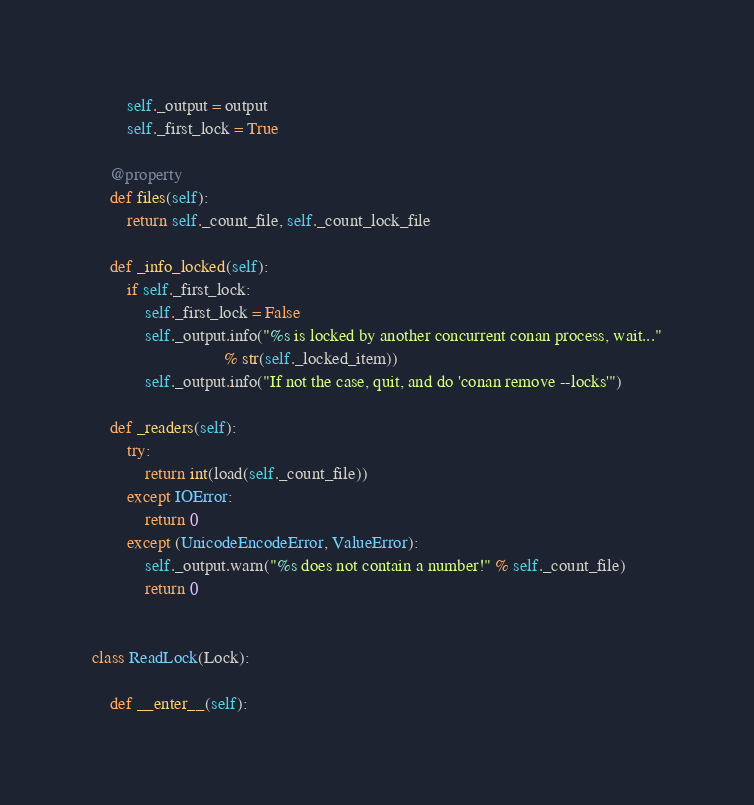<code> <loc_0><loc_0><loc_500><loc_500><_Python_>        self._output = output
        self._first_lock = True

    @property
    def files(self):
        return self._count_file, self._count_lock_file

    def _info_locked(self):
        if self._first_lock:
            self._first_lock = False
            self._output.info("%s is locked by another concurrent conan process, wait..."
                              % str(self._locked_item))
            self._output.info("If not the case, quit, and do 'conan remove --locks'")

    def _readers(self):
        try:
            return int(load(self._count_file))
        except IOError:
            return 0
        except (UnicodeEncodeError, ValueError):
            self._output.warn("%s does not contain a number!" % self._count_file)
            return 0


class ReadLock(Lock):

    def __enter__(self):</code> 